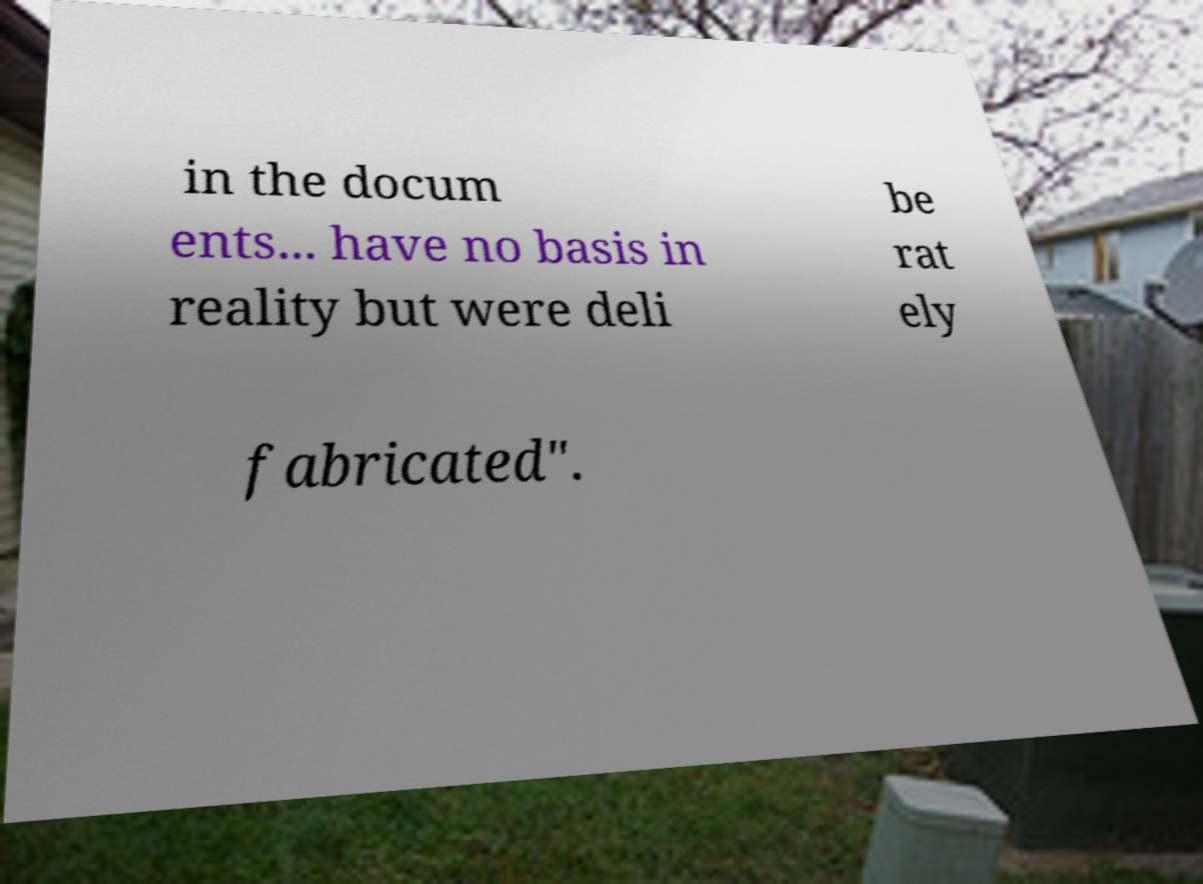What messages or text are displayed in this image? I need them in a readable, typed format. in the docum ents... have no basis in reality but were deli be rat ely fabricated". 